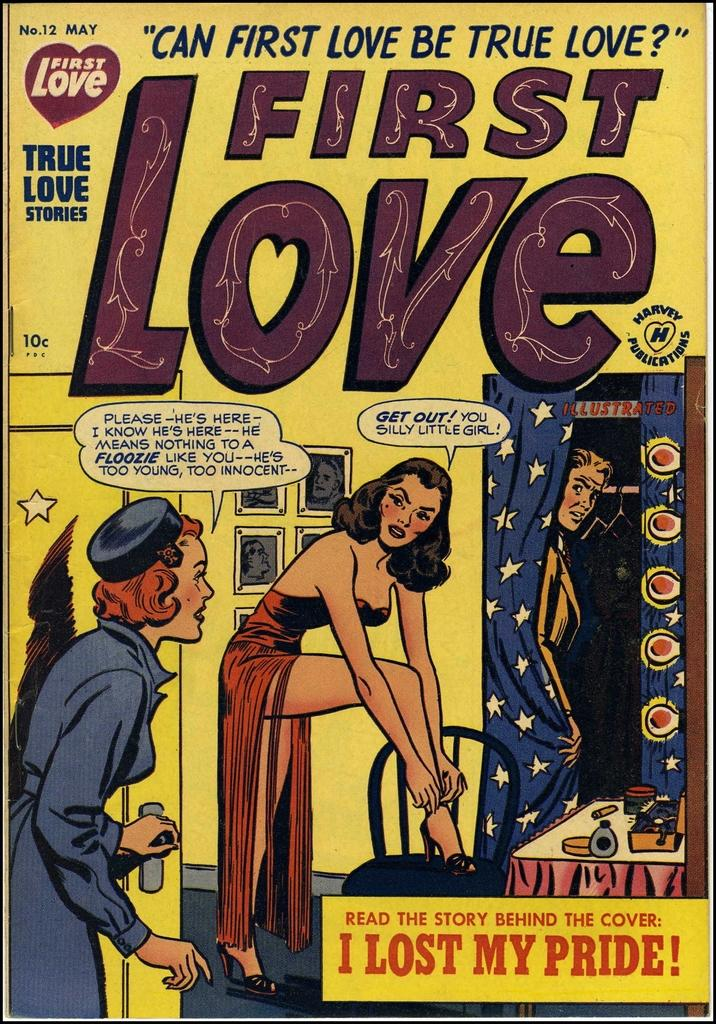<image>
Write a terse but informative summary of the picture. Issue number 12 of First Love Comics titled "can first love be true love?". 